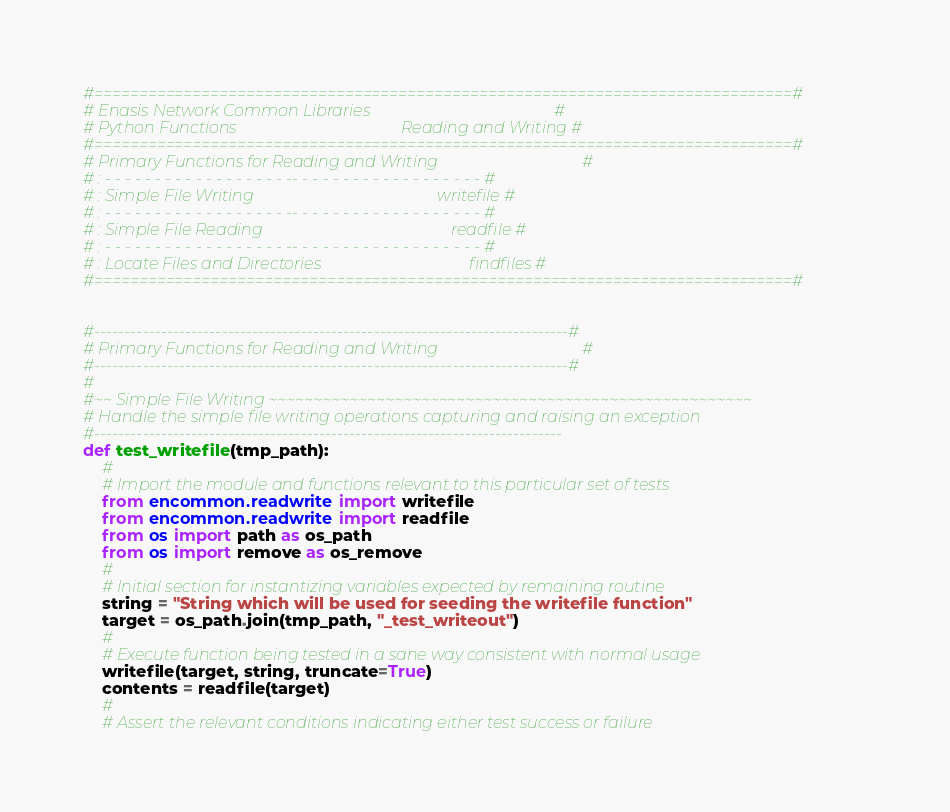Convert code to text. <code><loc_0><loc_0><loc_500><loc_500><_Python_>#==============================================================================#
# Enasis Network Common Libraries                                              #
# Python Functions                                         Reading and Writing #
#==============================================================================#
# Primary Functions for Reading and Writing                                    #
# : - - - - - - - - - - - - - - - - - - -- - - - - - - - - - - - - - - - - - - #
# : Simple File Writing                                              writefile #
# : - - - - - - - - - - - - - - - - - - -- - - - - - - - - - - - - - - - - - - #
# : Simple File Reading                                               readfile #
# : - - - - - - - - - - - - - - - - - - -- - - - - - - - - - - - - - - - - - - #
# : Locate Files and Directories                                     findfiles #
#==============================================================================#


#------------------------------------------------------------------------------#
# Primary Functions for Reading and Writing                                    #
#------------------------------------------------------------------------------#
#
#~~ Simple File Writing ~~~~~~~~~~~~~~~~~~~~~~~~~~~~~~~~~~~~~~~~~~~~~~~~~~~~~~
# Handle the simple file writing operations capturing and raising an exception
#-----------------------------------------------------------------------------
def test_writefile(tmp_path):
    #
    # Import the module and functions relevant to this particular set of tests
    from encommon.readwrite import writefile
    from encommon.readwrite import readfile
    from os import path as os_path
    from os import remove as os_remove
    #
    # Initial section for instantizing variables expected by remaining routine
    string = "String which will be used for seeding the writefile function"
    target = os_path.join(tmp_path, "_test_writeout")
    #
    # Execute function being tested in a sane way consistent with normal usage
    writefile(target, string, truncate=True)
    contents = readfile(target)
    #
    # Assert the relevant conditions indicating either test success or failure</code> 